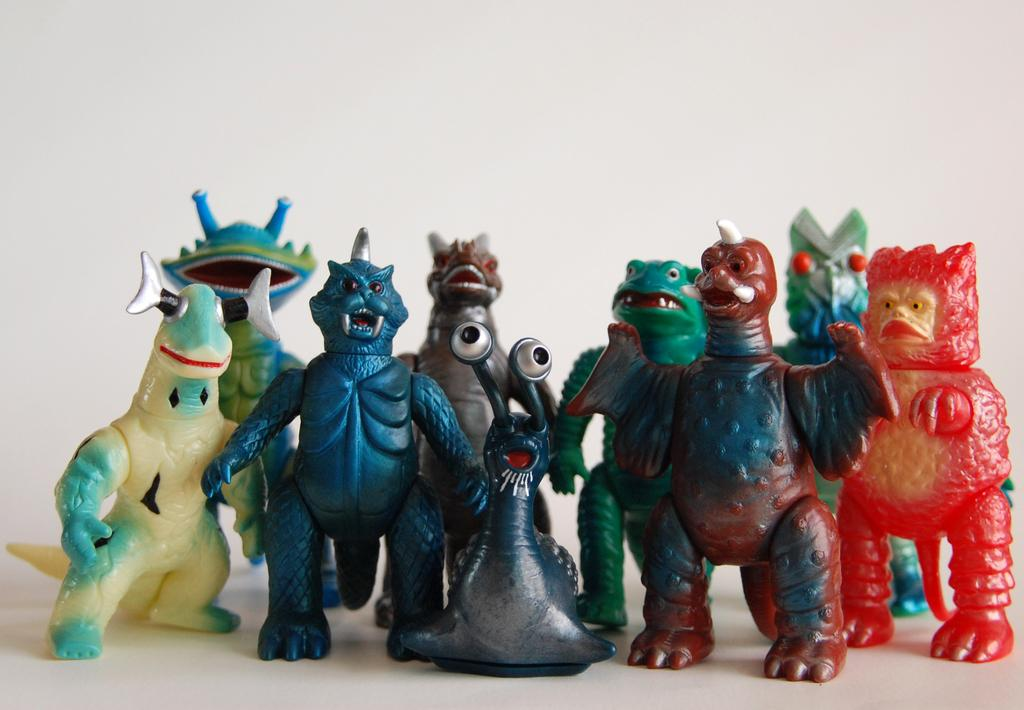What type of dolls are in the image? There are monster dolls in the image. What color is the surface the dolls are on? The surface they are on is white. What type of curve can be seen in the image? There is no curve present in the image; it features monster dolls on a white surface. What type of suit is the father wearing in the image? There is no father or suit present in the image. 